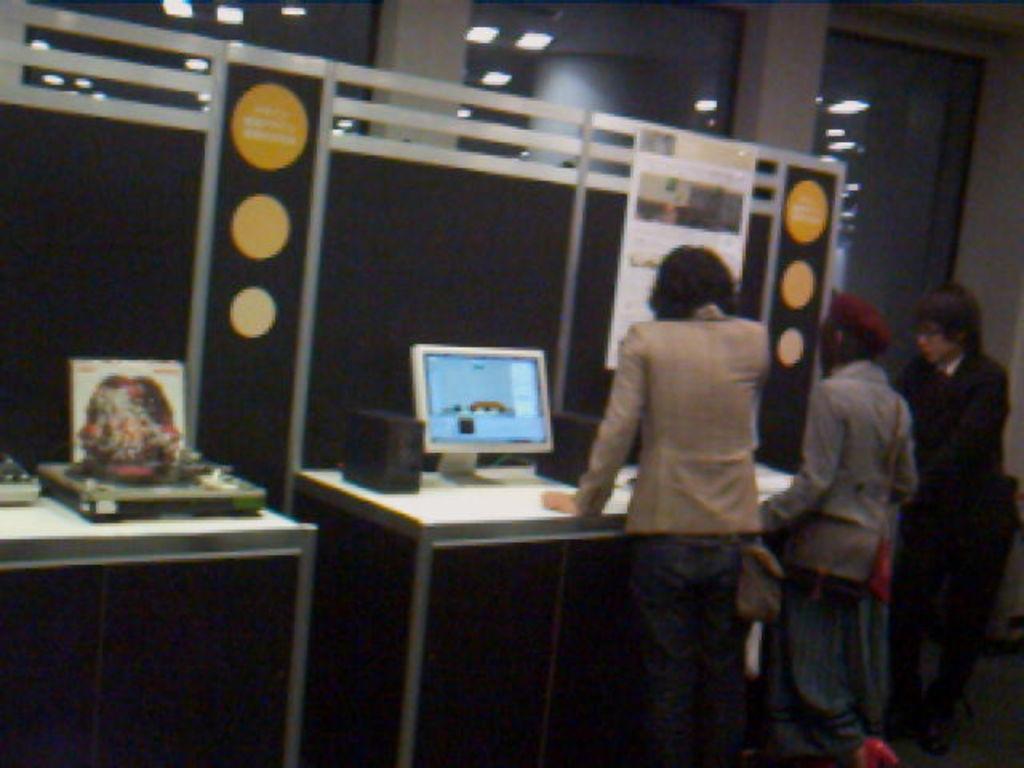In one or two sentences, can you explain what this image depicts? In the image we can see there are people who are standing and on table there is a monitor. 